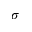<formula> <loc_0><loc_0><loc_500><loc_500>\sigma</formula> 